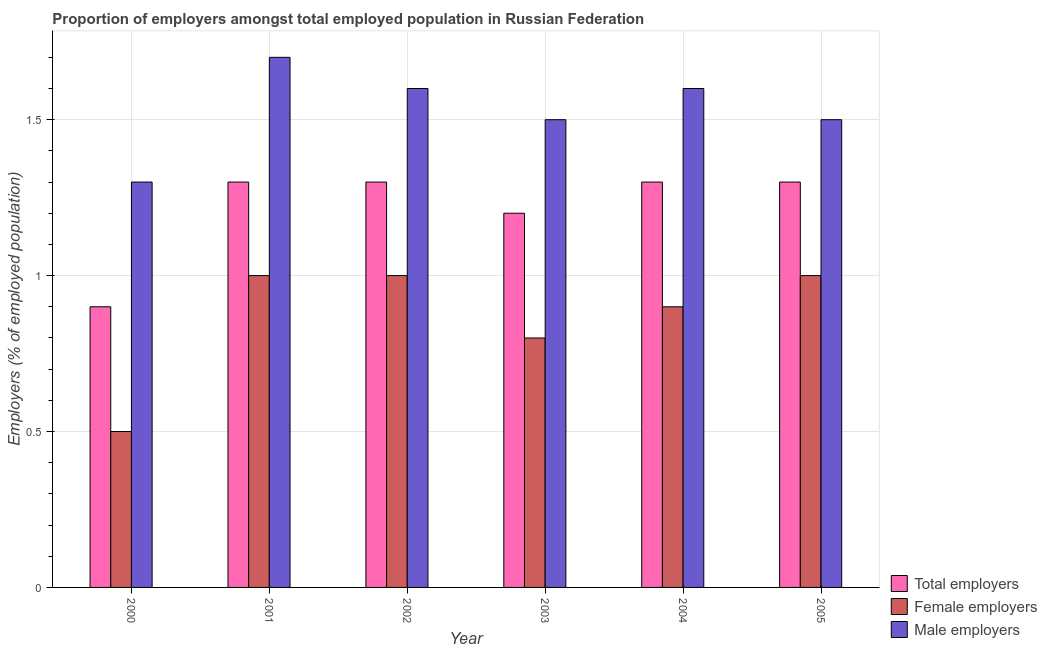Are the number of bars per tick equal to the number of legend labels?
Your response must be concise. Yes. Are the number of bars on each tick of the X-axis equal?
Make the answer very short. Yes. How many bars are there on the 4th tick from the left?
Your answer should be very brief. 3. What is the percentage of total employers in 2001?
Your answer should be very brief. 1.3. Across all years, what is the maximum percentage of total employers?
Give a very brief answer. 1.3. In which year was the percentage of female employers maximum?
Ensure brevity in your answer.  2001. In which year was the percentage of male employers minimum?
Make the answer very short. 2000. What is the total percentage of total employers in the graph?
Ensure brevity in your answer.  7.3. What is the difference between the percentage of male employers in 2001 and the percentage of total employers in 2002?
Your response must be concise. 0.1. What is the average percentage of female employers per year?
Offer a terse response. 0.87. In the year 2002, what is the difference between the percentage of male employers and percentage of total employers?
Keep it short and to the point. 0. What is the ratio of the percentage of total employers in 2000 to that in 2004?
Provide a succinct answer. 0.69. What is the difference between the highest and the second highest percentage of male employers?
Offer a terse response. 0.1. What is the difference between the highest and the lowest percentage of female employers?
Ensure brevity in your answer.  0.5. In how many years, is the percentage of female employers greater than the average percentage of female employers taken over all years?
Give a very brief answer. 4. Is the sum of the percentage of total employers in 2001 and 2004 greater than the maximum percentage of male employers across all years?
Offer a very short reply. Yes. What does the 1st bar from the left in 2005 represents?
Make the answer very short. Total employers. What does the 1st bar from the right in 2001 represents?
Provide a short and direct response. Male employers. How many years are there in the graph?
Offer a terse response. 6. What is the difference between two consecutive major ticks on the Y-axis?
Provide a short and direct response. 0.5. Does the graph contain any zero values?
Make the answer very short. No. Does the graph contain grids?
Offer a very short reply. Yes. Where does the legend appear in the graph?
Ensure brevity in your answer.  Bottom right. What is the title of the graph?
Your answer should be very brief. Proportion of employers amongst total employed population in Russian Federation. What is the label or title of the X-axis?
Provide a succinct answer. Year. What is the label or title of the Y-axis?
Ensure brevity in your answer.  Employers (% of employed population). What is the Employers (% of employed population) of Total employers in 2000?
Keep it short and to the point. 0.9. What is the Employers (% of employed population) of Male employers in 2000?
Your answer should be very brief. 1.3. What is the Employers (% of employed population) in Total employers in 2001?
Give a very brief answer. 1.3. What is the Employers (% of employed population) in Male employers in 2001?
Offer a terse response. 1.7. What is the Employers (% of employed population) of Total employers in 2002?
Provide a short and direct response. 1.3. What is the Employers (% of employed population) in Female employers in 2002?
Give a very brief answer. 1. What is the Employers (% of employed population) in Male employers in 2002?
Give a very brief answer. 1.6. What is the Employers (% of employed population) in Total employers in 2003?
Ensure brevity in your answer.  1.2. What is the Employers (% of employed population) of Female employers in 2003?
Your answer should be very brief. 0.8. What is the Employers (% of employed population) in Male employers in 2003?
Your answer should be very brief. 1.5. What is the Employers (% of employed population) in Total employers in 2004?
Your answer should be very brief. 1.3. What is the Employers (% of employed population) in Female employers in 2004?
Your response must be concise. 0.9. What is the Employers (% of employed population) of Male employers in 2004?
Your answer should be very brief. 1.6. What is the Employers (% of employed population) of Total employers in 2005?
Give a very brief answer. 1.3. What is the Employers (% of employed population) of Female employers in 2005?
Provide a short and direct response. 1. What is the Employers (% of employed population) of Male employers in 2005?
Your answer should be compact. 1.5. Across all years, what is the maximum Employers (% of employed population) of Total employers?
Offer a very short reply. 1.3. Across all years, what is the maximum Employers (% of employed population) of Female employers?
Keep it short and to the point. 1. Across all years, what is the maximum Employers (% of employed population) of Male employers?
Offer a terse response. 1.7. Across all years, what is the minimum Employers (% of employed population) in Total employers?
Keep it short and to the point. 0.9. Across all years, what is the minimum Employers (% of employed population) of Female employers?
Provide a short and direct response. 0.5. Across all years, what is the minimum Employers (% of employed population) in Male employers?
Give a very brief answer. 1.3. What is the total Employers (% of employed population) of Female employers in the graph?
Your answer should be compact. 5.2. What is the difference between the Employers (% of employed population) of Male employers in 2000 and that in 2001?
Offer a terse response. -0.4. What is the difference between the Employers (% of employed population) in Total employers in 2000 and that in 2002?
Make the answer very short. -0.4. What is the difference between the Employers (% of employed population) of Female employers in 2000 and that in 2002?
Give a very brief answer. -0.5. What is the difference between the Employers (% of employed population) of Male employers in 2000 and that in 2002?
Your answer should be very brief. -0.3. What is the difference between the Employers (% of employed population) of Male employers in 2000 and that in 2003?
Make the answer very short. -0.2. What is the difference between the Employers (% of employed population) in Total employers in 2000 and that in 2005?
Offer a very short reply. -0.4. What is the difference between the Employers (% of employed population) in Male employers in 2001 and that in 2002?
Offer a terse response. 0.1. What is the difference between the Employers (% of employed population) in Male employers in 2001 and that in 2003?
Offer a terse response. 0.2. What is the difference between the Employers (% of employed population) in Male employers in 2001 and that in 2004?
Make the answer very short. 0.1. What is the difference between the Employers (% of employed population) of Total employers in 2001 and that in 2005?
Keep it short and to the point. 0. What is the difference between the Employers (% of employed population) in Total employers in 2002 and that in 2003?
Provide a short and direct response. 0.1. What is the difference between the Employers (% of employed population) of Male employers in 2002 and that in 2004?
Provide a short and direct response. 0. What is the difference between the Employers (% of employed population) of Male employers in 2002 and that in 2005?
Provide a short and direct response. 0.1. What is the difference between the Employers (% of employed population) of Total employers in 2003 and that in 2004?
Keep it short and to the point. -0.1. What is the difference between the Employers (% of employed population) of Male employers in 2003 and that in 2005?
Give a very brief answer. 0. What is the difference between the Employers (% of employed population) of Total employers in 2004 and that in 2005?
Keep it short and to the point. 0. What is the difference between the Employers (% of employed population) in Female employers in 2004 and that in 2005?
Your answer should be very brief. -0.1. What is the difference between the Employers (% of employed population) of Male employers in 2004 and that in 2005?
Offer a very short reply. 0.1. What is the difference between the Employers (% of employed population) of Total employers in 2000 and the Employers (% of employed population) of Male employers in 2001?
Offer a very short reply. -0.8. What is the difference between the Employers (% of employed population) of Female employers in 2000 and the Employers (% of employed population) of Male employers in 2001?
Your answer should be compact. -1.2. What is the difference between the Employers (% of employed population) in Total employers in 2000 and the Employers (% of employed population) in Female employers in 2002?
Offer a terse response. -0.1. What is the difference between the Employers (% of employed population) of Total employers in 2000 and the Employers (% of employed population) of Male employers in 2003?
Give a very brief answer. -0.6. What is the difference between the Employers (% of employed population) in Female employers in 2000 and the Employers (% of employed population) in Male employers in 2003?
Make the answer very short. -1. What is the difference between the Employers (% of employed population) in Female employers in 2000 and the Employers (% of employed population) in Male employers in 2004?
Provide a succinct answer. -1.1. What is the difference between the Employers (% of employed population) in Total employers in 2000 and the Employers (% of employed population) in Male employers in 2005?
Make the answer very short. -0.6. What is the difference between the Employers (% of employed population) of Female employers in 2000 and the Employers (% of employed population) of Male employers in 2005?
Keep it short and to the point. -1. What is the difference between the Employers (% of employed population) in Total employers in 2001 and the Employers (% of employed population) in Male employers in 2002?
Give a very brief answer. -0.3. What is the difference between the Employers (% of employed population) in Female employers in 2001 and the Employers (% of employed population) in Male employers in 2002?
Your response must be concise. -0.6. What is the difference between the Employers (% of employed population) of Total employers in 2001 and the Employers (% of employed population) of Female employers in 2003?
Offer a terse response. 0.5. What is the difference between the Employers (% of employed population) of Total employers in 2001 and the Employers (% of employed population) of Female employers in 2004?
Offer a very short reply. 0.4. What is the difference between the Employers (% of employed population) of Total employers in 2001 and the Employers (% of employed population) of Male employers in 2004?
Make the answer very short. -0.3. What is the difference between the Employers (% of employed population) in Female employers in 2001 and the Employers (% of employed population) in Male employers in 2004?
Provide a succinct answer. -0.6. What is the difference between the Employers (% of employed population) of Total employers in 2001 and the Employers (% of employed population) of Female employers in 2005?
Your answer should be very brief. 0.3. What is the difference between the Employers (% of employed population) in Total employers in 2001 and the Employers (% of employed population) in Male employers in 2005?
Ensure brevity in your answer.  -0.2. What is the difference between the Employers (% of employed population) in Total employers in 2002 and the Employers (% of employed population) in Female employers in 2003?
Ensure brevity in your answer.  0.5. What is the difference between the Employers (% of employed population) of Total employers in 2002 and the Employers (% of employed population) of Male employers in 2003?
Provide a succinct answer. -0.2. What is the difference between the Employers (% of employed population) of Female employers in 2002 and the Employers (% of employed population) of Male employers in 2003?
Your response must be concise. -0.5. What is the difference between the Employers (% of employed population) in Total employers in 2002 and the Employers (% of employed population) in Female employers in 2004?
Your answer should be compact. 0.4. What is the difference between the Employers (% of employed population) of Total employers in 2002 and the Employers (% of employed population) of Male employers in 2004?
Provide a short and direct response. -0.3. What is the difference between the Employers (% of employed population) of Total employers in 2002 and the Employers (% of employed population) of Female employers in 2005?
Ensure brevity in your answer.  0.3. What is the difference between the Employers (% of employed population) of Total employers in 2003 and the Employers (% of employed population) of Female employers in 2004?
Your answer should be compact. 0.3. What is the difference between the Employers (% of employed population) in Total employers in 2003 and the Employers (% of employed population) in Female employers in 2005?
Your answer should be compact. 0.2. What is the difference between the Employers (% of employed population) of Total employers in 2003 and the Employers (% of employed population) of Male employers in 2005?
Keep it short and to the point. -0.3. What is the difference between the Employers (% of employed population) in Female employers in 2003 and the Employers (% of employed population) in Male employers in 2005?
Your response must be concise. -0.7. What is the difference between the Employers (% of employed population) of Total employers in 2004 and the Employers (% of employed population) of Female employers in 2005?
Provide a succinct answer. 0.3. What is the average Employers (% of employed population) in Total employers per year?
Your answer should be very brief. 1.22. What is the average Employers (% of employed population) in Female employers per year?
Your answer should be compact. 0.87. What is the average Employers (% of employed population) of Male employers per year?
Provide a succinct answer. 1.53. In the year 2000, what is the difference between the Employers (% of employed population) in Total employers and Employers (% of employed population) in Female employers?
Ensure brevity in your answer.  0.4. In the year 2000, what is the difference between the Employers (% of employed population) of Total employers and Employers (% of employed population) of Male employers?
Your response must be concise. -0.4. In the year 2000, what is the difference between the Employers (% of employed population) of Female employers and Employers (% of employed population) of Male employers?
Keep it short and to the point. -0.8. In the year 2001, what is the difference between the Employers (% of employed population) in Total employers and Employers (% of employed population) in Female employers?
Your response must be concise. 0.3. In the year 2001, what is the difference between the Employers (% of employed population) of Total employers and Employers (% of employed population) of Male employers?
Offer a terse response. -0.4. In the year 2002, what is the difference between the Employers (% of employed population) in Female employers and Employers (% of employed population) in Male employers?
Provide a short and direct response. -0.6. In the year 2003, what is the difference between the Employers (% of employed population) in Total employers and Employers (% of employed population) in Male employers?
Your answer should be very brief. -0.3. In the year 2003, what is the difference between the Employers (% of employed population) in Female employers and Employers (% of employed population) in Male employers?
Ensure brevity in your answer.  -0.7. In the year 2004, what is the difference between the Employers (% of employed population) of Total employers and Employers (% of employed population) of Male employers?
Your answer should be very brief. -0.3. In the year 2005, what is the difference between the Employers (% of employed population) of Total employers and Employers (% of employed population) of Female employers?
Provide a short and direct response. 0.3. What is the ratio of the Employers (% of employed population) of Total employers in 2000 to that in 2001?
Your answer should be very brief. 0.69. What is the ratio of the Employers (% of employed population) in Male employers in 2000 to that in 2001?
Provide a short and direct response. 0.76. What is the ratio of the Employers (% of employed population) of Total employers in 2000 to that in 2002?
Make the answer very short. 0.69. What is the ratio of the Employers (% of employed population) of Female employers in 2000 to that in 2002?
Give a very brief answer. 0.5. What is the ratio of the Employers (% of employed population) of Male employers in 2000 to that in 2002?
Ensure brevity in your answer.  0.81. What is the ratio of the Employers (% of employed population) in Total employers in 2000 to that in 2003?
Offer a terse response. 0.75. What is the ratio of the Employers (% of employed population) of Male employers in 2000 to that in 2003?
Your response must be concise. 0.87. What is the ratio of the Employers (% of employed population) of Total employers in 2000 to that in 2004?
Give a very brief answer. 0.69. What is the ratio of the Employers (% of employed population) of Female employers in 2000 to that in 2004?
Provide a short and direct response. 0.56. What is the ratio of the Employers (% of employed population) of Male employers in 2000 to that in 2004?
Provide a succinct answer. 0.81. What is the ratio of the Employers (% of employed population) of Total employers in 2000 to that in 2005?
Keep it short and to the point. 0.69. What is the ratio of the Employers (% of employed population) in Male employers in 2000 to that in 2005?
Your answer should be compact. 0.87. What is the ratio of the Employers (% of employed population) in Total employers in 2001 to that in 2002?
Offer a very short reply. 1. What is the ratio of the Employers (% of employed population) in Male employers in 2001 to that in 2003?
Provide a short and direct response. 1.13. What is the ratio of the Employers (% of employed population) of Total employers in 2001 to that in 2005?
Your answer should be compact. 1. What is the ratio of the Employers (% of employed population) of Male employers in 2001 to that in 2005?
Give a very brief answer. 1.13. What is the ratio of the Employers (% of employed population) of Total employers in 2002 to that in 2003?
Keep it short and to the point. 1.08. What is the ratio of the Employers (% of employed population) in Female employers in 2002 to that in 2003?
Your response must be concise. 1.25. What is the ratio of the Employers (% of employed population) in Male employers in 2002 to that in 2003?
Offer a very short reply. 1.07. What is the ratio of the Employers (% of employed population) in Total employers in 2002 to that in 2004?
Make the answer very short. 1. What is the ratio of the Employers (% of employed population) in Female employers in 2002 to that in 2004?
Your answer should be very brief. 1.11. What is the ratio of the Employers (% of employed population) in Male employers in 2002 to that in 2004?
Keep it short and to the point. 1. What is the ratio of the Employers (% of employed population) in Female employers in 2002 to that in 2005?
Your answer should be very brief. 1. What is the ratio of the Employers (% of employed population) in Male employers in 2002 to that in 2005?
Make the answer very short. 1.07. What is the ratio of the Employers (% of employed population) in Total employers in 2003 to that in 2004?
Offer a very short reply. 0.92. What is the ratio of the Employers (% of employed population) of Female employers in 2003 to that in 2005?
Ensure brevity in your answer.  0.8. What is the ratio of the Employers (% of employed population) in Male employers in 2004 to that in 2005?
Offer a very short reply. 1.07. 